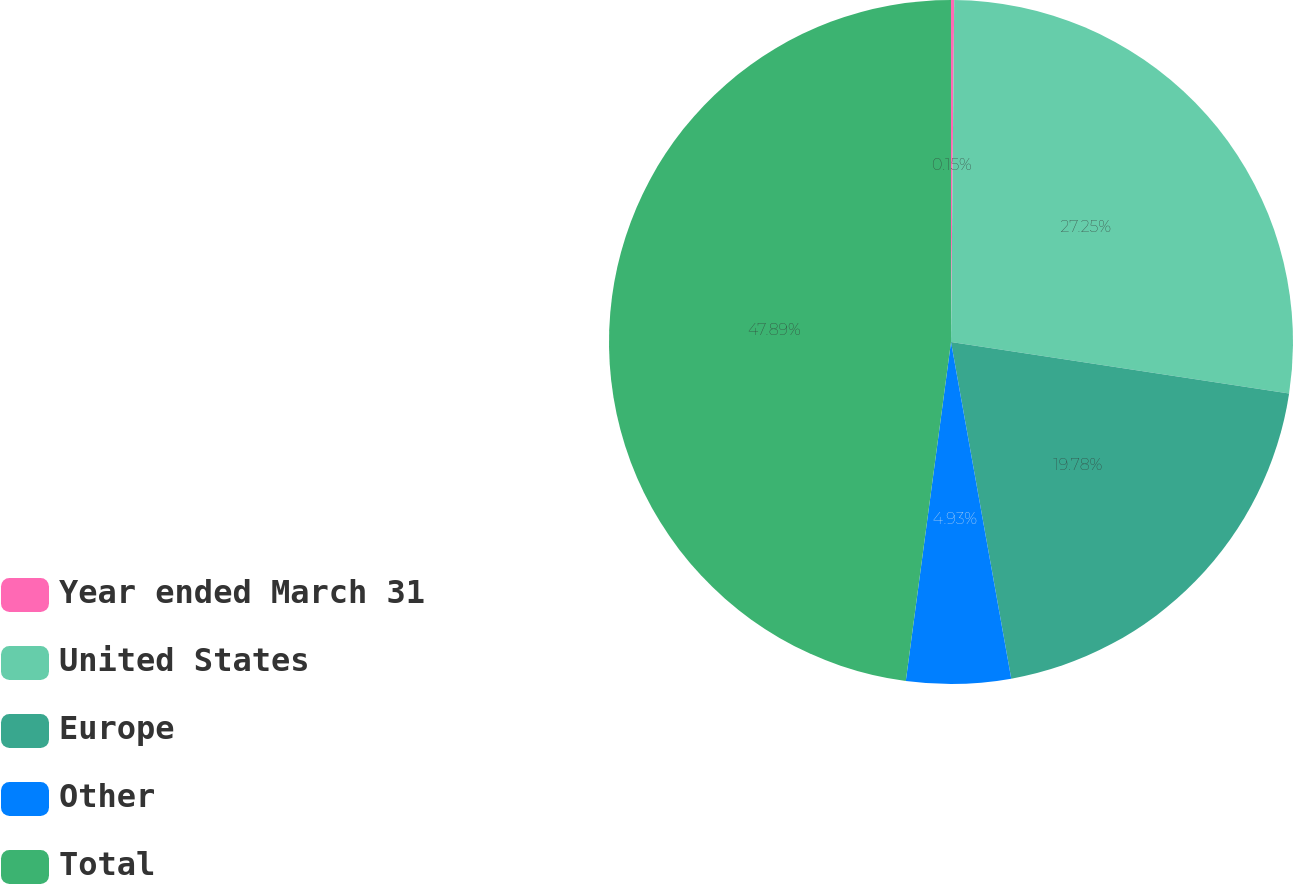Convert chart to OTSL. <chart><loc_0><loc_0><loc_500><loc_500><pie_chart><fcel>Year ended March 31<fcel>United States<fcel>Europe<fcel>Other<fcel>Total<nl><fcel>0.15%<fcel>27.25%<fcel>19.78%<fcel>4.93%<fcel>47.89%<nl></chart> 